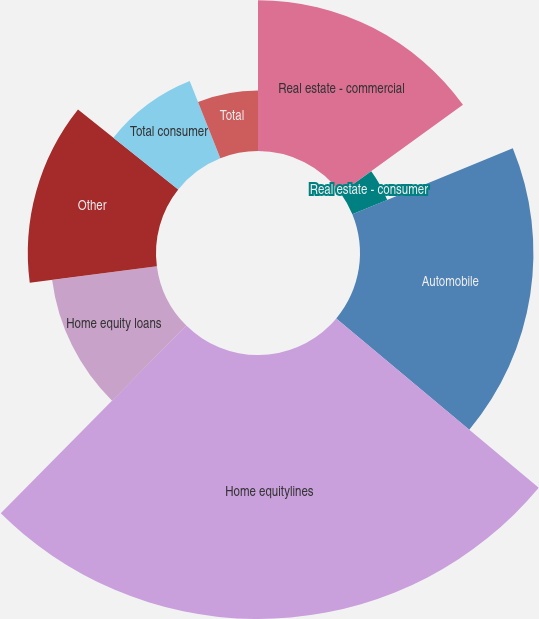Convert chart to OTSL. <chart><loc_0><loc_0><loc_500><loc_500><pie_chart><fcel>Real estate - commercial<fcel>Real estate - consumer<fcel>Automobile<fcel>Home equitylines<fcel>Home equity loans<fcel>Other<fcel>Total consumer<fcel>Total<nl><fcel>15.04%<fcel>3.76%<fcel>17.29%<fcel>26.32%<fcel>10.53%<fcel>12.78%<fcel>8.27%<fcel>6.02%<nl></chart> 